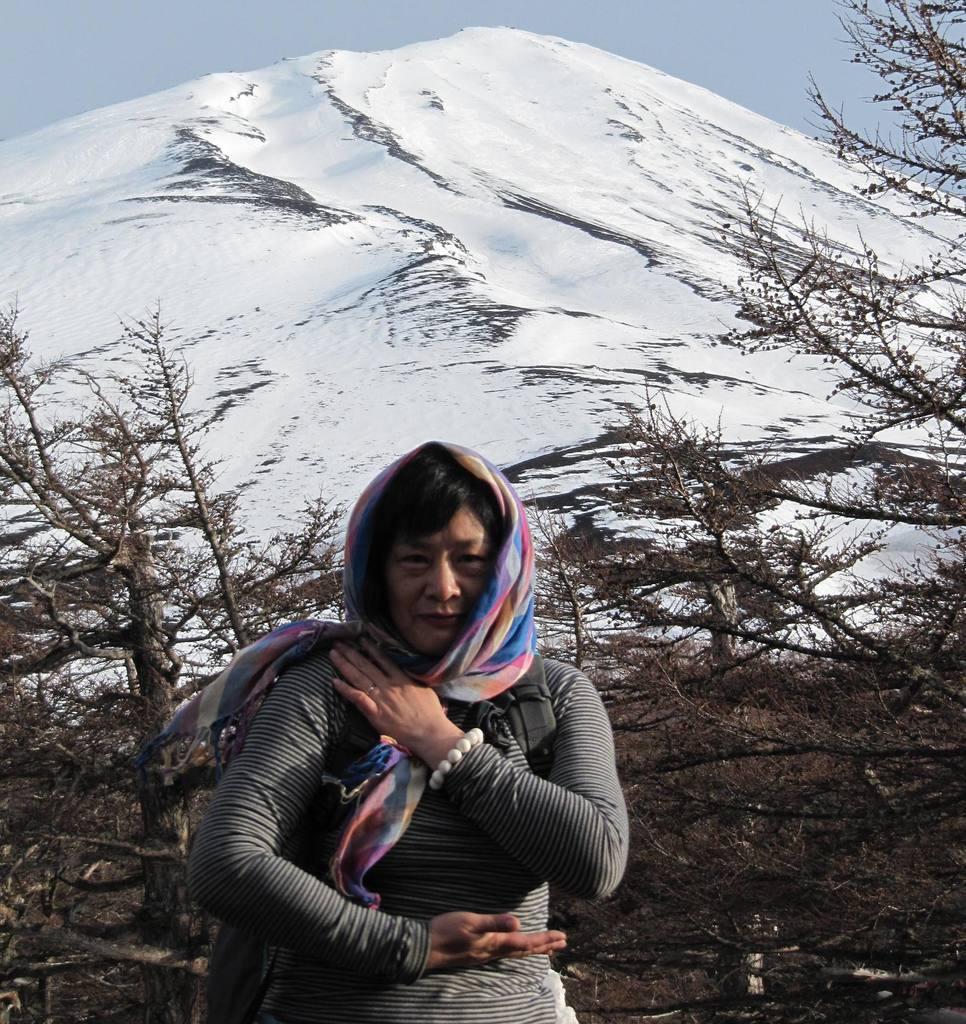How would you summarize this image in a sentence or two? At the bottom of this image, there is a person having a scarf and smiling. In the background, there are trees, a mountain on which there is snow and there are clouds in the sky. 